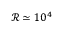<formula> <loc_0><loc_0><loc_500><loc_500>\mathcal { R } \simeq 1 0 ^ { 4 }</formula> 